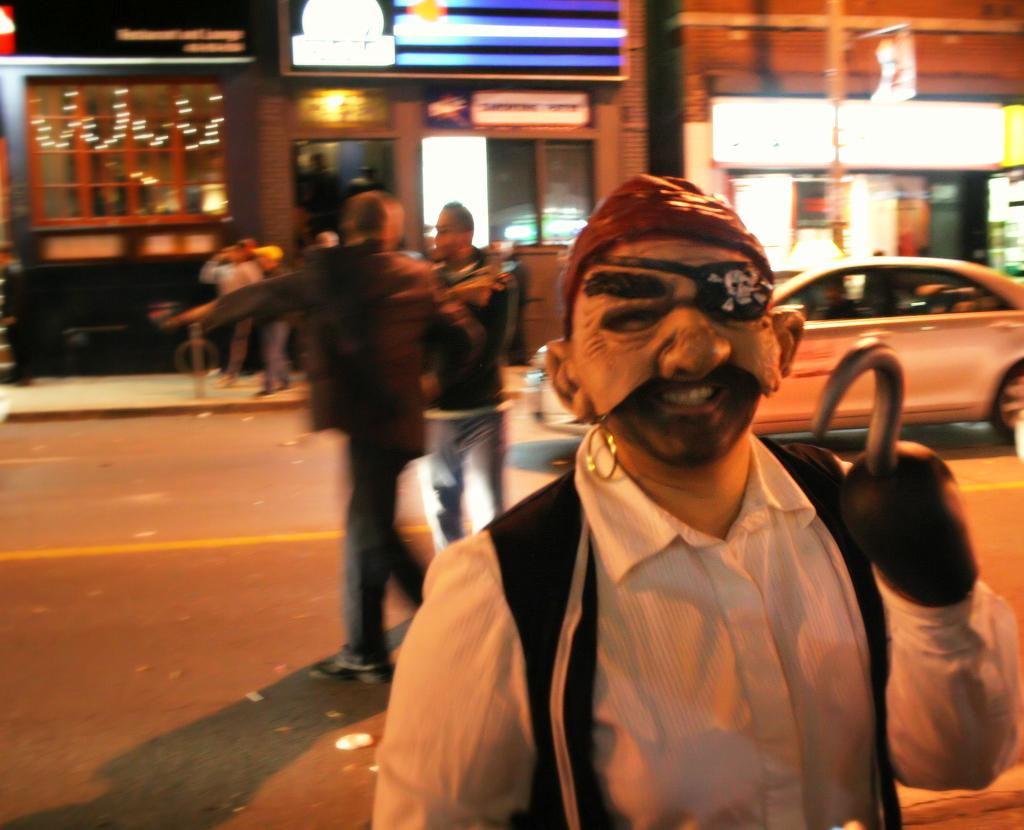What is the main subject of the image? There is a person in the image. What is the person wearing? The person is wearing a mask. What object is the person holding? The person is holding a walking stick. What can be seen in the background of the image? There is a store, people standing on the road, and a motor vehicle in the background. What type of government is depicted in the image? There is no depiction of a government in the image; it features a person wearing a mask and holding a walking stick, along with a background scene. How many experts can be seen in the image? There are no experts present in the image. 